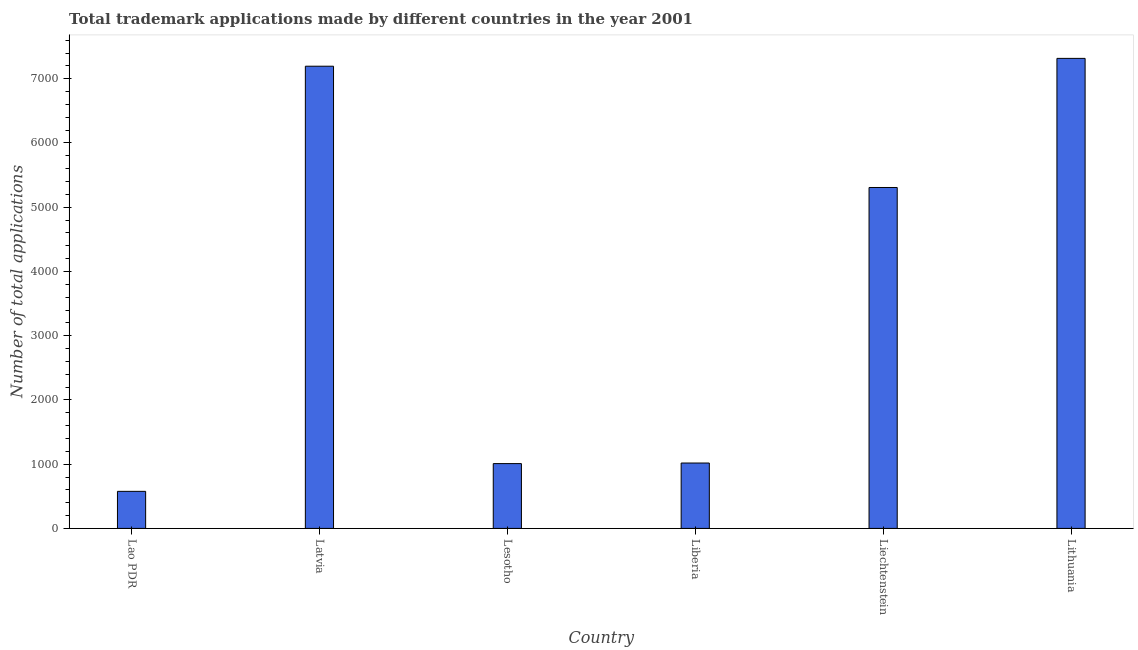Does the graph contain any zero values?
Keep it short and to the point. No. What is the title of the graph?
Keep it short and to the point. Total trademark applications made by different countries in the year 2001. What is the label or title of the Y-axis?
Your response must be concise. Number of total applications. What is the number of trademark applications in Lao PDR?
Your response must be concise. 577. Across all countries, what is the maximum number of trademark applications?
Make the answer very short. 7317. Across all countries, what is the minimum number of trademark applications?
Keep it short and to the point. 577. In which country was the number of trademark applications maximum?
Provide a short and direct response. Lithuania. In which country was the number of trademark applications minimum?
Provide a succinct answer. Lao PDR. What is the sum of the number of trademark applications?
Ensure brevity in your answer.  2.24e+04. What is the difference between the number of trademark applications in Lao PDR and Latvia?
Your response must be concise. -6618. What is the average number of trademark applications per country?
Your response must be concise. 3737. What is the median number of trademark applications?
Your answer should be compact. 3162.5. What is the ratio of the number of trademark applications in Lao PDR to that in Lithuania?
Your answer should be compact. 0.08. Is the number of trademark applications in Lao PDR less than that in Latvia?
Ensure brevity in your answer.  Yes. What is the difference between the highest and the second highest number of trademark applications?
Offer a terse response. 122. Is the sum of the number of trademark applications in Liberia and Liechtenstein greater than the maximum number of trademark applications across all countries?
Your answer should be compact. No. What is the difference between the highest and the lowest number of trademark applications?
Your response must be concise. 6740. Are all the bars in the graph horizontal?
Offer a terse response. No. What is the difference between two consecutive major ticks on the Y-axis?
Give a very brief answer. 1000. Are the values on the major ticks of Y-axis written in scientific E-notation?
Your answer should be very brief. No. What is the Number of total applications of Lao PDR?
Your answer should be very brief. 577. What is the Number of total applications in Latvia?
Your response must be concise. 7195. What is the Number of total applications of Lesotho?
Your response must be concise. 1009. What is the Number of total applications in Liberia?
Give a very brief answer. 1018. What is the Number of total applications of Liechtenstein?
Offer a very short reply. 5307. What is the Number of total applications in Lithuania?
Ensure brevity in your answer.  7317. What is the difference between the Number of total applications in Lao PDR and Latvia?
Offer a very short reply. -6618. What is the difference between the Number of total applications in Lao PDR and Lesotho?
Offer a very short reply. -432. What is the difference between the Number of total applications in Lao PDR and Liberia?
Provide a short and direct response. -441. What is the difference between the Number of total applications in Lao PDR and Liechtenstein?
Make the answer very short. -4730. What is the difference between the Number of total applications in Lao PDR and Lithuania?
Ensure brevity in your answer.  -6740. What is the difference between the Number of total applications in Latvia and Lesotho?
Give a very brief answer. 6186. What is the difference between the Number of total applications in Latvia and Liberia?
Provide a succinct answer. 6177. What is the difference between the Number of total applications in Latvia and Liechtenstein?
Offer a terse response. 1888. What is the difference between the Number of total applications in Latvia and Lithuania?
Keep it short and to the point. -122. What is the difference between the Number of total applications in Lesotho and Liechtenstein?
Offer a terse response. -4298. What is the difference between the Number of total applications in Lesotho and Lithuania?
Give a very brief answer. -6308. What is the difference between the Number of total applications in Liberia and Liechtenstein?
Provide a short and direct response. -4289. What is the difference between the Number of total applications in Liberia and Lithuania?
Offer a very short reply. -6299. What is the difference between the Number of total applications in Liechtenstein and Lithuania?
Your answer should be very brief. -2010. What is the ratio of the Number of total applications in Lao PDR to that in Latvia?
Keep it short and to the point. 0.08. What is the ratio of the Number of total applications in Lao PDR to that in Lesotho?
Ensure brevity in your answer.  0.57. What is the ratio of the Number of total applications in Lao PDR to that in Liberia?
Offer a very short reply. 0.57. What is the ratio of the Number of total applications in Lao PDR to that in Liechtenstein?
Provide a succinct answer. 0.11. What is the ratio of the Number of total applications in Lao PDR to that in Lithuania?
Your answer should be compact. 0.08. What is the ratio of the Number of total applications in Latvia to that in Lesotho?
Offer a very short reply. 7.13. What is the ratio of the Number of total applications in Latvia to that in Liberia?
Give a very brief answer. 7.07. What is the ratio of the Number of total applications in Latvia to that in Liechtenstein?
Provide a succinct answer. 1.36. What is the ratio of the Number of total applications in Lesotho to that in Liechtenstein?
Offer a very short reply. 0.19. What is the ratio of the Number of total applications in Lesotho to that in Lithuania?
Provide a succinct answer. 0.14. What is the ratio of the Number of total applications in Liberia to that in Liechtenstein?
Offer a terse response. 0.19. What is the ratio of the Number of total applications in Liberia to that in Lithuania?
Give a very brief answer. 0.14. What is the ratio of the Number of total applications in Liechtenstein to that in Lithuania?
Offer a terse response. 0.72. 